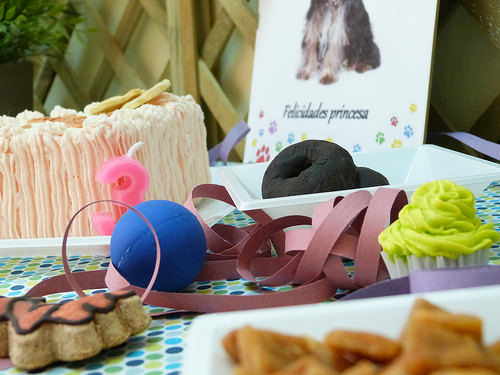<image>
Can you confirm if the ball is on the paper? Yes. Looking at the image, I can see the ball is positioned on top of the paper, with the paper providing support. Where is the ball in relation to the cake? Is it in front of the cake? Yes. The ball is positioned in front of the cake, appearing closer to the camera viewpoint. 